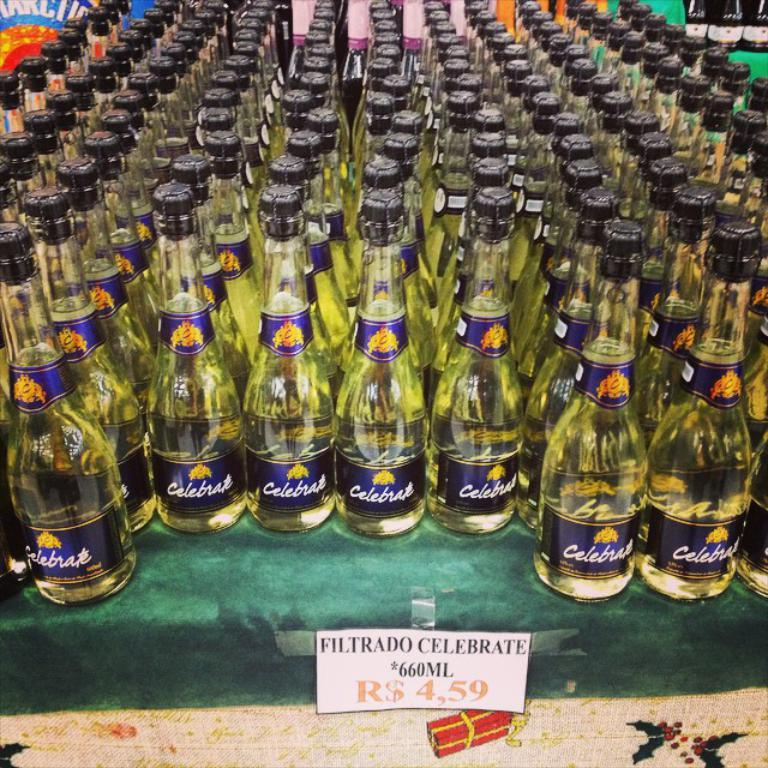<image>
Provide a brief description of the given image. A store display consisting of many bottles of Filtrado Celebrate wine. 